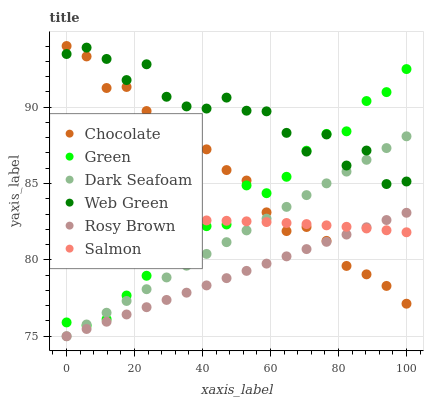Does Rosy Brown have the minimum area under the curve?
Answer yes or no. Yes. Does Web Green have the maximum area under the curve?
Answer yes or no. Yes. Does Salmon have the minimum area under the curve?
Answer yes or no. No. Does Salmon have the maximum area under the curve?
Answer yes or no. No. Is Dark Seafoam the smoothest?
Answer yes or no. Yes. Is Web Green the roughest?
Answer yes or no. Yes. Is Salmon the smoothest?
Answer yes or no. No. Is Salmon the roughest?
Answer yes or no. No. Does Rosy Brown have the lowest value?
Answer yes or no. Yes. Does Salmon have the lowest value?
Answer yes or no. No. Does Chocolate have the highest value?
Answer yes or no. Yes. Does Web Green have the highest value?
Answer yes or no. No. Is Salmon less than Web Green?
Answer yes or no. Yes. Is Web Green greater than Salmon?
Answer yes or no. Yes. Does Dark Seafoam intersect Salmon?
Answer yes or no. Yes. Is Dark Seafoam less than Salmon?
Answer yes or no. No. Is Dark Seafoam greater than Salmon?
Answer yes or no. No. Does Salmon intersect Web Green?
Answer yes or no. No. 